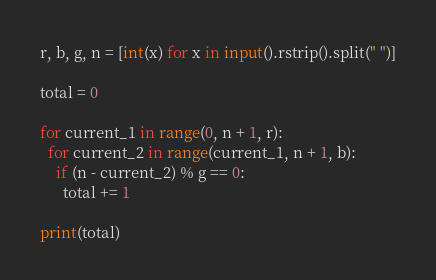<code> <loc_0><loc_0><loc_500><loc_500><_Python_>r, b, g, n = [int(x) for x in input().rstrip().split(" ")]

total = 0

for current_1 in range(0, n + 1, r):
  for current_2 in range(current_1, n + 1, b):
    if (n - current_2) % g == 0:
      total += 1

print(total)</code> 